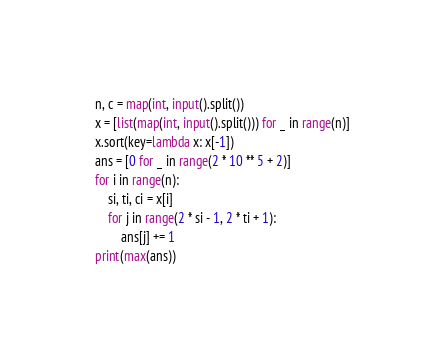<code> <loc_0><loc_0><loc_500><loc_500><_Python_>n, c = map(int, input().split())
x = [list(map(int, input().split())) for _ in range(n)]
x.sort(key=lambda x: x[-1])
ans = [0 for _ in range(2 * 10 ** 5 + 2)]
for i in range(n):
    si, ti, ci = x[i]
    for j in range(2 * si - 1, 2 * ti + 1):
        ans[j] += 1
print(max(ans))
</code> 